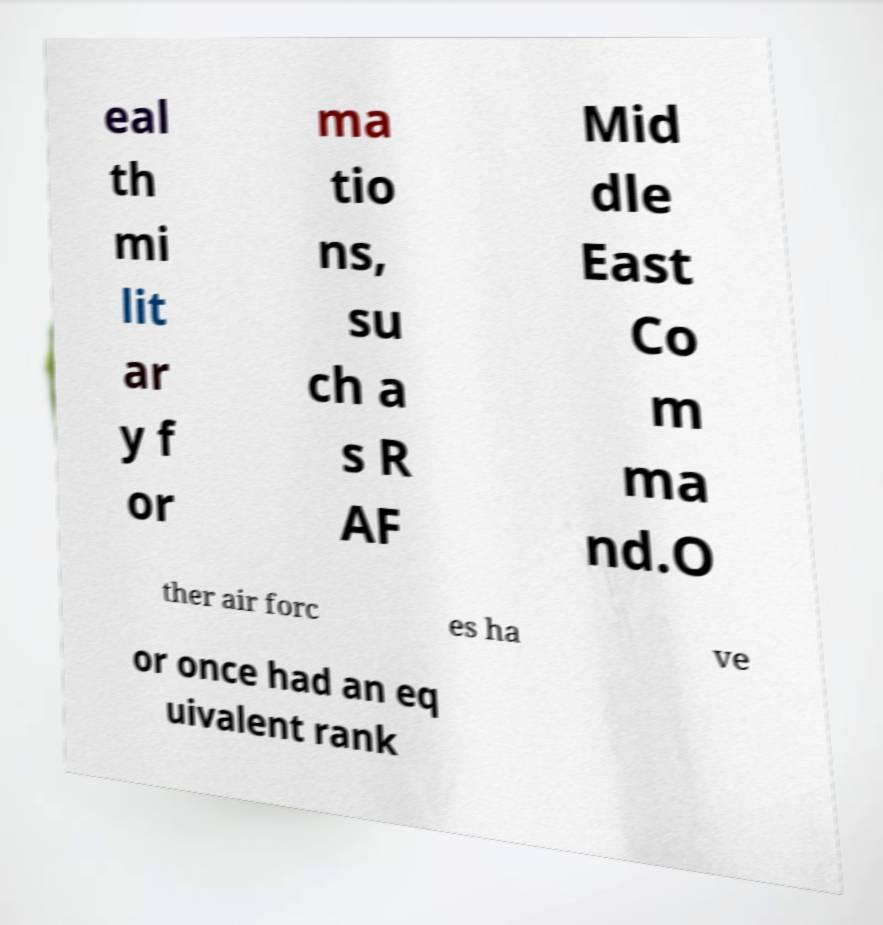I need the written content from this picture converted into text. Can you do that? eal th mi lit ar y f or ma tio ns, su ch a s R AF Mid dle East Co m ma nd.O ther air forc es ha ve or once had an eq uivalent rank 